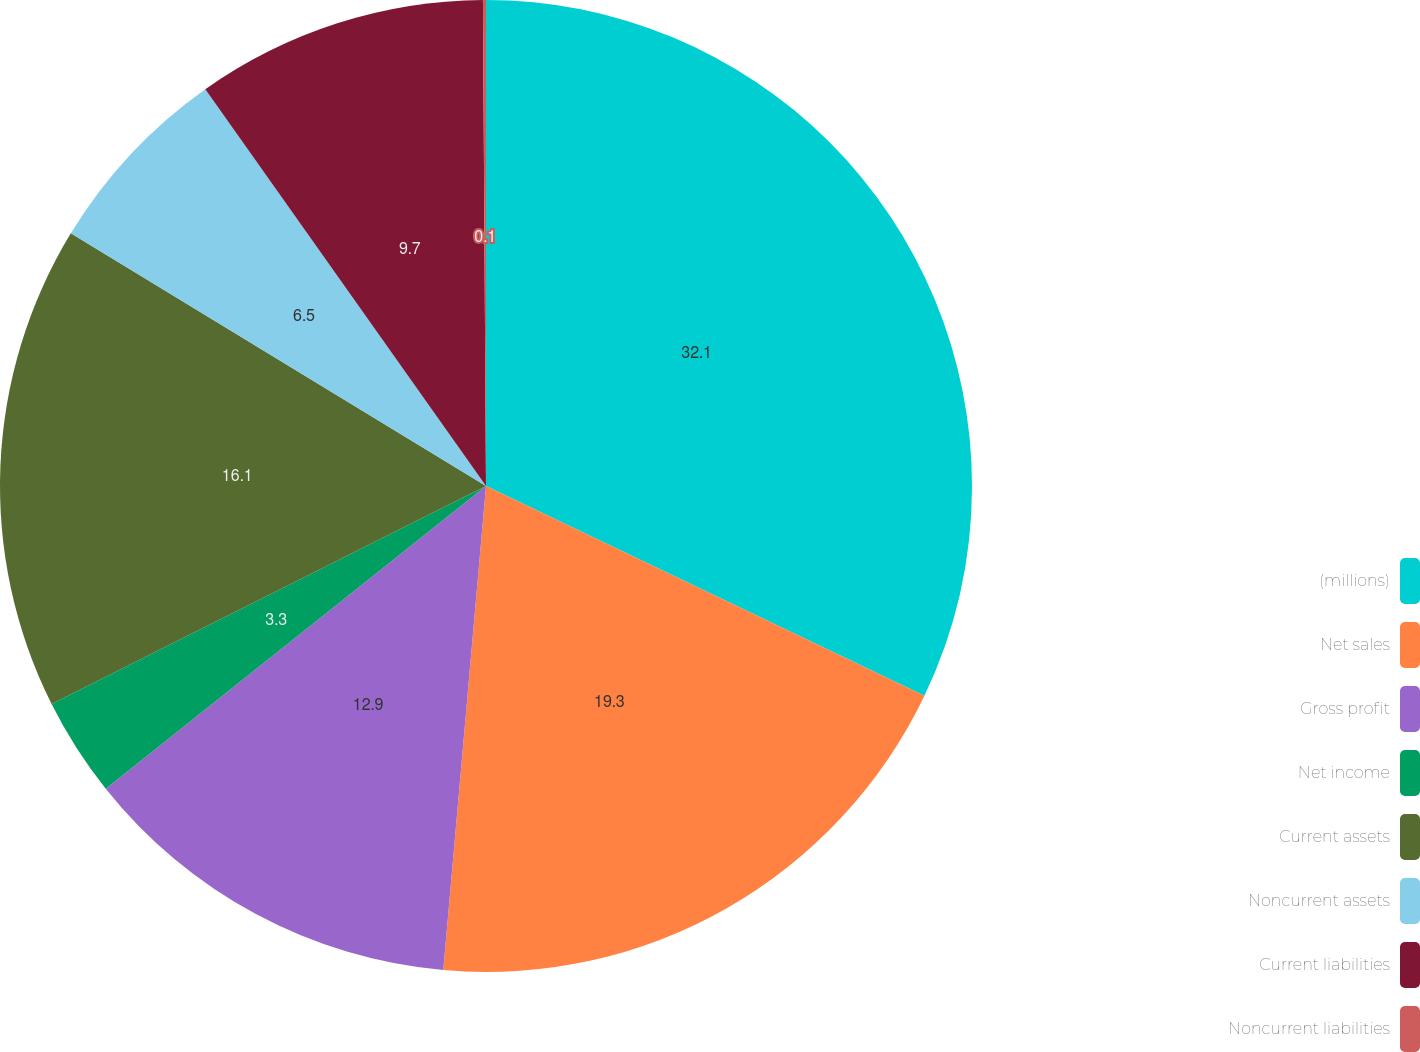Convert chart. <chart><loc_0><loc_0><loc_500><loc_500><pie_chart><fcel>(millions)<fcel>Net sales<fcel>Gross profit<fcel>Net income<fcel>Current assets<fcel>Noncurrent assets<fcel>Current liabilities<fcel>Noncurrent liabilities<nl><fcel>32.1%<fcel>19.3%<fcel>12.9%<fcel>3.3%<fcel>16.1%<fcel>6.5%<fcel>9.7%<fcel>0.1%<nl></chart> 